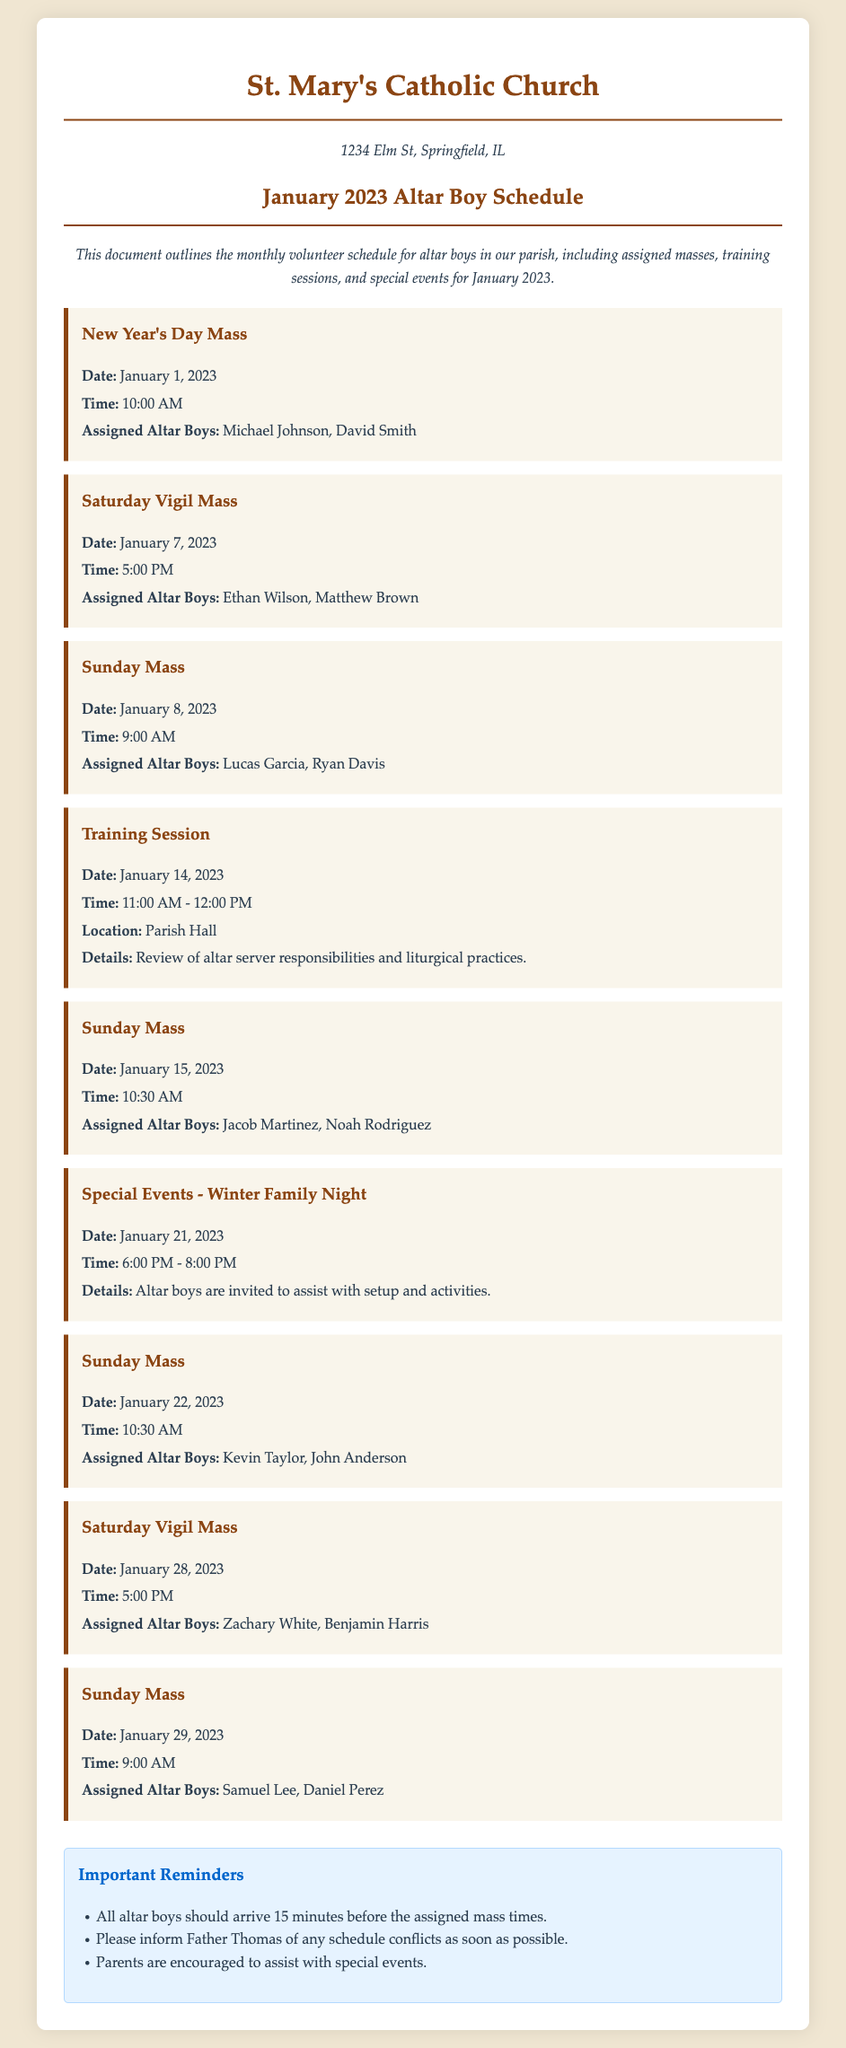What is the first event listed in the schedule? The first event listed is the New Year's Day Mass on January 1, 2023.
Answer: New Year's Day Mass What time is the Saturday Vigil Mass on January 7, 2023? The document states that the Saturday Vigil Mass is at 5:00 PM on January 7, 2023.
Answer: 5:00 PM Who are the altar boys assigned for the Sunday Mass on January 15, 2023? The assigned altar boys for the January 15, 2023 Sunday Mass are Jacob Martinez and Noah Rodriguez.
Answer: Jacob Martinez, Noah Rodriguez How long is the training session scheduled for January 14, 2023? The training session is scheduled for 1 hour, from 11:00 AM to 12:00 PM.
Answer: 1 hour What special event is mentioned for January 21, 2023? The special event mentioned for January 21, 2023, is Winter Family Night.
Answer: Winter Family Night How many altar boys are assigned for the Sunday Mass on January 29, 2023? The document lists two altar boys assigned for the January 29, 2023 Sunday Mass.
Answer: Two What should altar boys do if they have a schedule conflict? Altar boys should inform Father Thomas of any schedule conflicts as soon as possible.
Answer: Inform Father Thomas Where is the training session held? The training session is held in the Parish Hall.
Answer: Parish Hall 